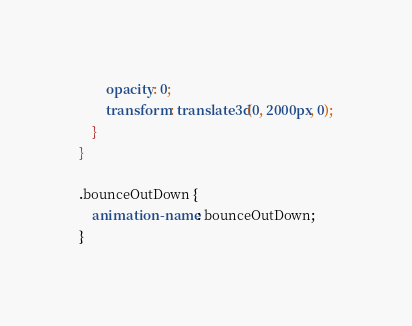Convert code to text. <code><loc_0><loc_0><loc_500><loc_500><_CSS_>        opacity: 0;
        transform: translate3d(0, 2000px, 0);
    }
}

.bounceOutDown {
    animation-name: bounceOutDown;
}
</code> 